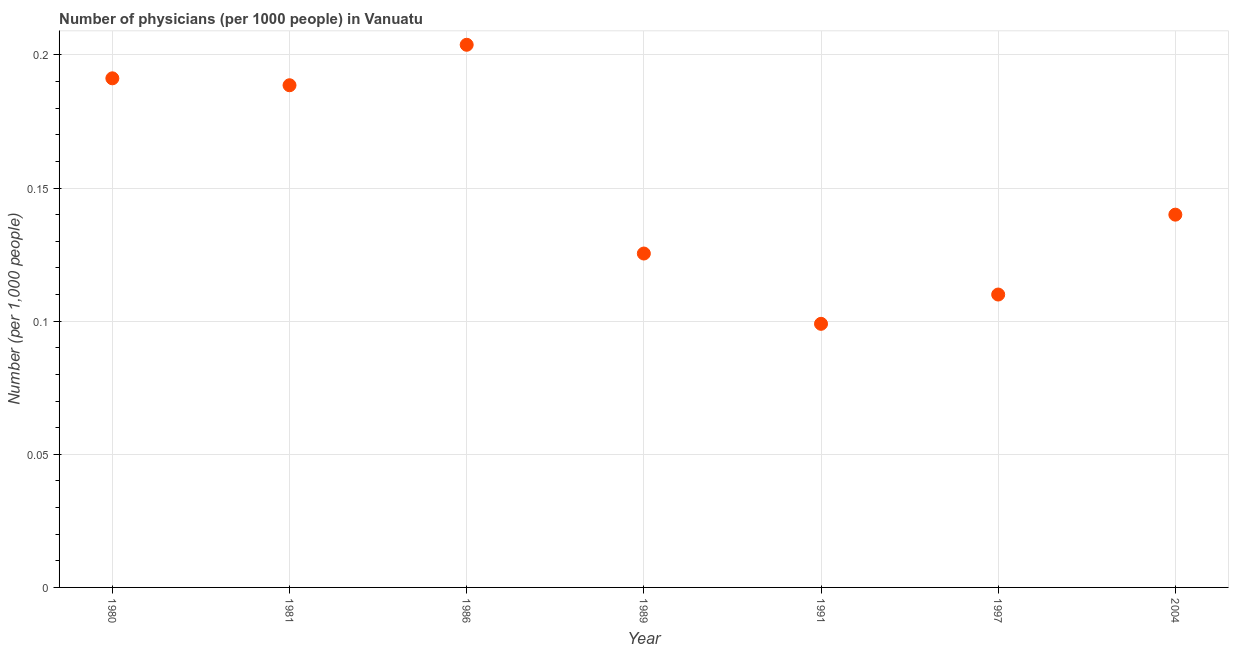What is the number of physicians in 1989?
Your response must be concise. 0.13. Across all years, what is the maximum number of physicians?
Provide a succinct answer. 0.2. Across all years, what is the minimum number of physicians?
Make the answer very short. 0.1. In which year was the number of physicians maximum?
Offer a very short reply. 1986. In which year was the number of physicians minimum?
Your answer should be very brief. 1991. What is the sum of the number of physicians?
Your response must be concise. 1.06. What is the difference between the number of physicians in 1989 and 2004?
Make the answer very short. -0.01. What is the average number of physicians per year?
Give a very brief answer. 0.15. What is the median number of physicians?
Your response must be concise. 0.14. Do a majority of the years between 1986 and 1997 (inclusive) have number of physicians greater than 0.05 ?
Offer a very short reply. Yes. What is the ratio of the number of physicians in 1986 to that in 1989?
Provide a succinct answer. 1.63. Is the number of physicians in 1997 less than that in 2004?
Your answer should be compact. Yes. What is the difference between the highest and the second highest number of physicians?
Keep it short and to the point. 0.01. Is the sum of the number of physicians in 1986 and 2004 greater than the maximum number of physicians across all years?
Provide a succinct answer. Yes. What is the difference between the highest and the lowest number of physicians?
Your answer should be compact. 0.1. In how many years, is the number of physicians greater than the average number of physicians taken over all years?
Offer a terse response. 3. Does the number of physicians monotonically increase over the years?
Your response must be concise. No. What is the difference between two consecutive major ticks on the Y-axis?
Your answer should be very brief. 0.05. What is the title of the graph?
Your answer should be compact. Number of physicians (per 1000 people) in Vanuatu. What is the label or title of the Y-axis?
Offer a very short reply. Number (per 1,0 people). What is the Number (per 1,000 people) in 1980?
Offer a terse response. 0.19. What is the Number (per 1,000 people) in 1981?
Your response must be concise. 0.19. What is the Number (per 1,000 people) in 1986?
Offer a terse response. 0.2. What is the Number (per 1,000 people) in 1989?
Keep it short and to the point. 0.13. What is the Number (per 1,000 people) in 1991?
Give a very brief answer. 0.1. What is the Number (per 1,000 people) in 1997?
Your response must be concise. 0.11. What is the Number (per 1,000 people) in 2004?
Your response must be concise. 0.14. What is the difference between the Number (per 1,000 people) in 1980 and 1981?
Provide a short and direct response. 0. What is the difference between the Number (per 1,000 people) in 1980 and 1986?
Make the answer very short. -0.01. What is the difference between the Number (per 1,000 people) in 1980 and 1989?
Keep it short and to the point. 0.07. What is the difference between the Number (per 1,000 people) in 1980 and 1991?
Give a very brief answer. 0.09. What is the difference between the Number (per 1,000 people) in 1980 and 1997?
Ensure brevity in your answer.  0.08. What is the difference between the Number (per 1,000 people) in 1980 and 2004?
Provide a succinct answer. 0.05. What is the difference between the Number (per 1,000 people) in 1981 and 1986?
Make the answer very short. -0.02. What is the difference between the Number (per 1,000 people) in 1981 and 1989?
Offer a terse response. 0.06. What is the difference between the Number (per 1,000 people) in 1981 and 1991?
Offer a very short reply. 0.09. What is the difference between the Number (per 1,000 people) in 1981 and 1997?
Provide a short and direct response. 0.08. What is the difference between the Number (per 1,000 people) in 1981 and 2004?
Make the answer very short. 0.05. What is the difference between the Number (per 1,000 people) in 1986 and 1989?
Offer a terse response. 0.08. What is the difference between the Number (per 1,000 people) in 1986 and 1991?
Offer a terse response. 0.1. What is the difference between the Number (per 1,000 people) in 1986 and 1997?
Give a very brief answer. 0.09. What is the difference between the Number (per 1,000 people) in 1986 and 2004?
Provide a short and direct response. 0.06. What is the difference between the Number (per 1,000 people) in 1989 and 1991?
Your answer should be very brief. 0.03. What is the difference between the Number (per 1,000 people) in 1989 and 1997?
Provide a short and direct response. 0.02. What is the difference between the Number (per 1,000 people) in 1989 and 2004?
Offer a terse response. -0.01. What is the difference between the Number (per 1,000 people) in 1991 and 1997?
Your response must be concise. -0.01. What is the difference between the Number (per 1,000 people) in 1991 and 2004?
Your answer should be very brief. -0.04. What is the difference between the Number (per 1,000 people) in 1997 and 2004?
Your answer should be compact. -0.03. What is the ratio of the Number (per 1,000 people) in 1980 to that in 1986?
Ensure brevity in your answer.  0.94. What is the ratio of the Number (per 1,000 people) in 1980 to that in 1989?
Your answer should be compact. 1.52. What is the ratio of the Number (per 1,000 people) in 1980 to that in 1991?
Your answer should be very brief. 1.93. What is the ratio of the Number (per 1,000 people) in 1980 to that in 1997?
Provide a succinct answer. 1.74. What is the ratio of the Number (per 1,000 people) in 1980 to that in 2004?
Your answer should be very brief. 1.37. What is the ratio of the Number (per 1,000 people) in 1981 to that in 1986?
Provide a short and direct response. 0.93. What is the ratio of the Number (per 1,000 people) in 1981 to that in 1989?
Offer a terse response. 1.5. What is the ratio of the Number (per 1,000 people) in 1981 to that in 1991?
Keep it short and to the point. 1.91. What is the ratio of the Number (per 1,000 people) in 1981 to that in 1997?
Make the answer very short. 1.72. What is the ratio of the Number (per 1,000 people) in 1981 to that in 2004?
Make the answer very short. 1.35. What is the ratio of the Number (per 1,000 people) in 1986 to that in 1989?
Keep it short and to the point. 1.62. What is the ratio of the Number (per 1,000 people) in 1986 to that in 1991?
Make the answer very short. 2.06. What is the ratio of the Number (per 1,000 people) in 1986 to that in 1997?
Offer a terse response. 1.85. What is the ratio of the Number (per 1,000 people) in 1986 to that in 2004?
Keep it short and to the point. 1.46. What is the ratio of the Number (per 1,000 people) in 1989 to that in 1991?
Ensure brevity in your answer.  1.27. What is the ratio of the Number (per 1,000 people) in 1989 to that in 1997?
Provide a short and direct response. 1.14. What is the ratio of the Number (per 1,000 people) in 1989 to that in 2004?
Your answer should be compact. 0.9. What is the ratio of the Number (per 1,000 people) in 1991 to that in 2004?
Provide a succinct answer. 0.71. What is the ratio of the Number (per 1,000 people) in 1997 to that in 2004?
Keep it short and to the point. 0.79. 